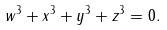Convert formula to latex. <formula><loc_0><loc_0><loc_500><loc_500>w ^ { 3 } + x ^ { 3 } + y ^ { 3 } + z ^ { 3 } = 0 .</formula> 